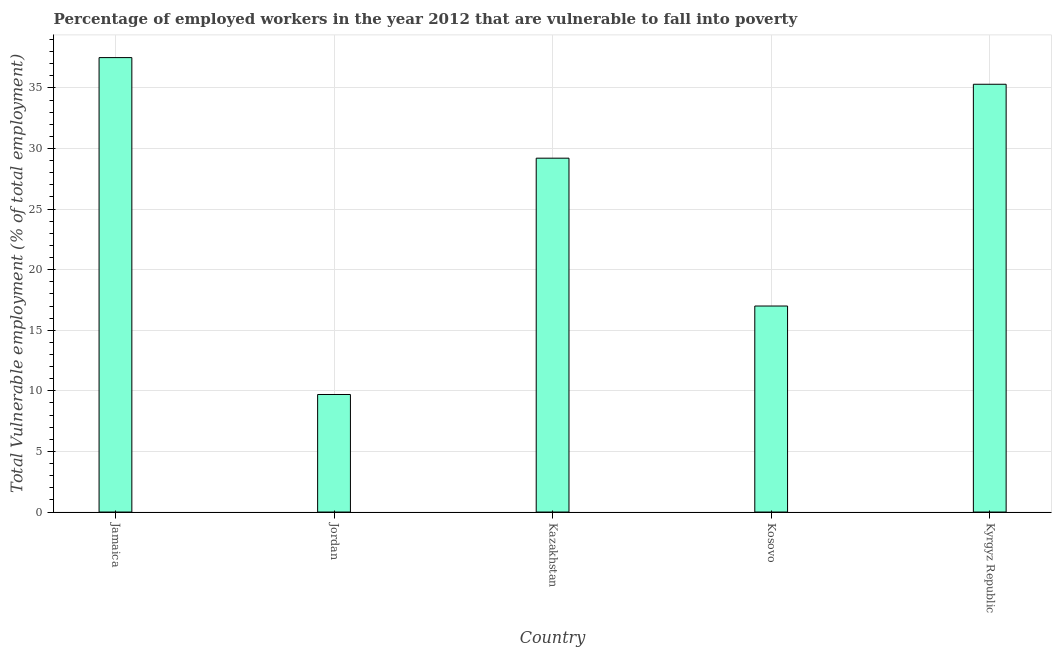Does the graph contain any zero values?
Provide a short and direct response. No. What is the title of the graph?
Keep it short and to the point. Percentage of employed workers in the year 2012 that are vulnerable to fall into poverty. What is the label or title of the X-axis?
Your answer should be very brief. Country. What is the label or title of the Y-axis?
Your answer should be compact. Total Vulnerable employment (% of total employment). What is the total vulnerable employment in Kosovo?
Your answer should be very brief. 17. Across all countries, what is the maximum total vulnerable employment?
Provide a succinct answer. 37.5. Across all countries, what is the minimum total vulnerable employment?
Provide a succinct answer. 9.7. In which country was the total vulnerable employment maximum?
Ensure brevity in your answer.  Jamaica. In which country was the total vulnerable employment minimum?
Give a very brief answer. Jordan. What is the sum of the total vulnerable employment?
Keep it short and to the point. 128.7. What is the difference between the total vulnerable employment in Jamaica and Kosovo?
Make the answer very short. 20.5. What is the average total vulnerable employment per country?
Keep it short and to the point. 25.74. What is the median total vulnerable employment?
Make the answer very short. 29.2. In how many countries, is the total vulnerable employment greater than 12 %?
Offer a terse response. 4. What is the ratio of the total vulnerable employment in Jordan to that in Kazakhstan?
Ensure brevity in your answer.  0.33. What is the difference between the highest and the second highest total vulnerable employment?
Provide a succinct answer. 2.2. What is the difference between the highest and the lowest total vulnerable employment?
Provide a succinct answer. 27.8. How many bars are there?
Provide a short and direct response. 5. Are all the bars in the graph horizontal?
Your answer should be compact. No. What is the Total Vulnerable employment (% of total employment) in Jamaica?
Your response must be concise. 37.5. What is the Total Vulnerable employment (% of total employment) of Jordan?
Keep it short and to the point. 9.7. What is the Total Vulnerable employment (% of total employment) in Kazakhstan?
Give a very brief answer. 29.2. What is the Total Vulnerable employment (% of total employment) in Kyrgyz Republic?
Your answer should be compact. 35.3. What is the difference between the Total Vulnerable employment (% of total employment) in Jamaica and Jordan?
Ensure brevity in your answer.  27.8. What is the difference between the Total Vulnerable employment (% of total employment) in Jamaica and Kosovo?
Keep it short and to the point. 20.5. What is the difference between the Total Vulnerable employment (% of total employment) in Jamaica and Kyrgyz Republic?
Offer a very short reply. 2.2. What is the difference between the Total Vulnerable employment (% of total employment) in Jordan and Kazakhstan?
Provide a succinct answer. -19.5. What is the difference between the Total Vulnerable employment (% of total employment) in Jordan and Kosovo?
Provide a short and direct response. -7.3. What is the difference between the Total Vulnerable employment (% of total employment) in Jordan and Kyrgyz Republic?
Offer a terse response. -25.6. What is the difference between the Total Vulnerable employment (% of total employment) in Kosovo and Kyrgyz Republic?
Offer a very short reply. -18.3. What is the ratio of the Total Vulnerable employment (% of total employment) in Jamaica to that in Jordan?
Your answer should be very brief. 3.87. What is the ratio of the Total Vulnerable employment (% of total employment) in Jamaica to that in Kazakhstan?
Provide a short and direct response. 1.28. What is the ratio of the Total Vulnerable employment (% of total employment) in Jamaica to that in Kosovo?
Your answer should be compact. 2.21. What is the ratio of the Total Vulnerable employment (% of total employment) in Jamaica to that in Kyrgyz Republic?
Give a very brief answer. 1.06. What is the ratio of the Total Vulnerable employment (% of total employment) in Jordan to that in Kazakhstan?
Offer a very short reply. 0.33. What is the ratio of the Total Vulnerable employment (% of total employment) in Jordan to that in Kosovo?
Provide a short and direct response. 0.57. What is the ratio of the Total Vulnerable employment (% of total employment) in Jordan to that in Kyrgyz Republic?
Ensure brevity in your answer.  0.28. What is the ratio of the Total Vulnerable employment (% of total employment) in Kazakhstan to that in Kosovo?
Make the answer very short. 1.72. What is the ratio of the Total Vulnerable employment (% of total employment) in Kazakhstan to that in Kyrgyz Republic?
Offer a very short reply. 0.83. What is the ratio of the Total Vulnerable employment (% of total employment) in Kosovo to that in Kyrgyz Republic?
Your answer should be very brief. 0.48. 